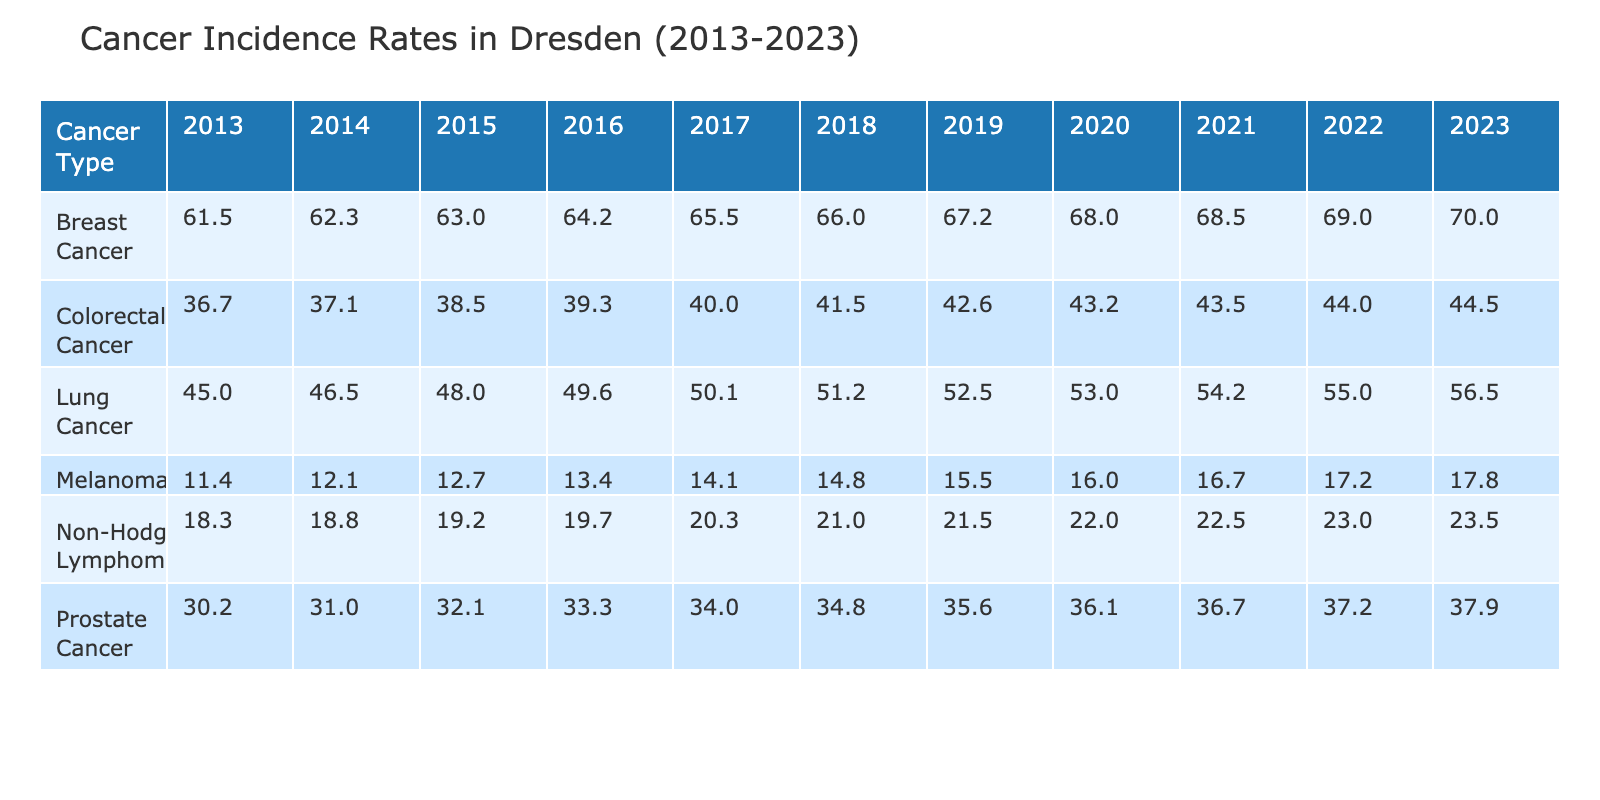What was the incidence rate of Lung Cancer in Dresden in 2020? The table shows the incidence rates for different cancer types across various years. By locating the row for Lung Cancer and the column for the year 2020, I find the value, which is 53.0.
Answer: 53.0 Which cancer type had the highest incidence rate in 2023? Reviewing the table for the year 2023, I see that the highest incidence rate corresponds to Breast Cancer, with a value of 70.0.
Answer: Breast Cancer What is the average incidence rate of Colorectal Cancer from 2013 to 2023? I will sum the incidence rates for Colorectal Cancer across the years: 36.7 + 37.1 + 38.5 + 39.3 + 40.0 + 41.5 + 43.2 + 43.5 + 44.0 + 44.5 = 480.8. Then, I divide this sum by the number of years (11), resulting in an average of approximately 43.3.
Answer: 43.3 Did the incidence rate of Non-Hodgkin Lymphoma increase every year from 2013 to 2023? By examining the table year by year for Non-Hodgkin Lymphoma, I confirm that the values are: 18.3, 18.8, 19.2, 19.7, 20.3, 21.0, 21.5, 22.0, 22.5, 23.0, and 23.5. This shows a consistent increase over the years without exception.
Answer: Yes What was the difference between the incidence rate of Prostate Cancer in 2013 and 2023? From the table, I find the incidence rate for Prostate Cancer in 2013 is 30.2 and in 2023 it is 37.9. To find the difference, I subtract 30.2 from 37.9, which equals 7.7.
Answer: 7.7 